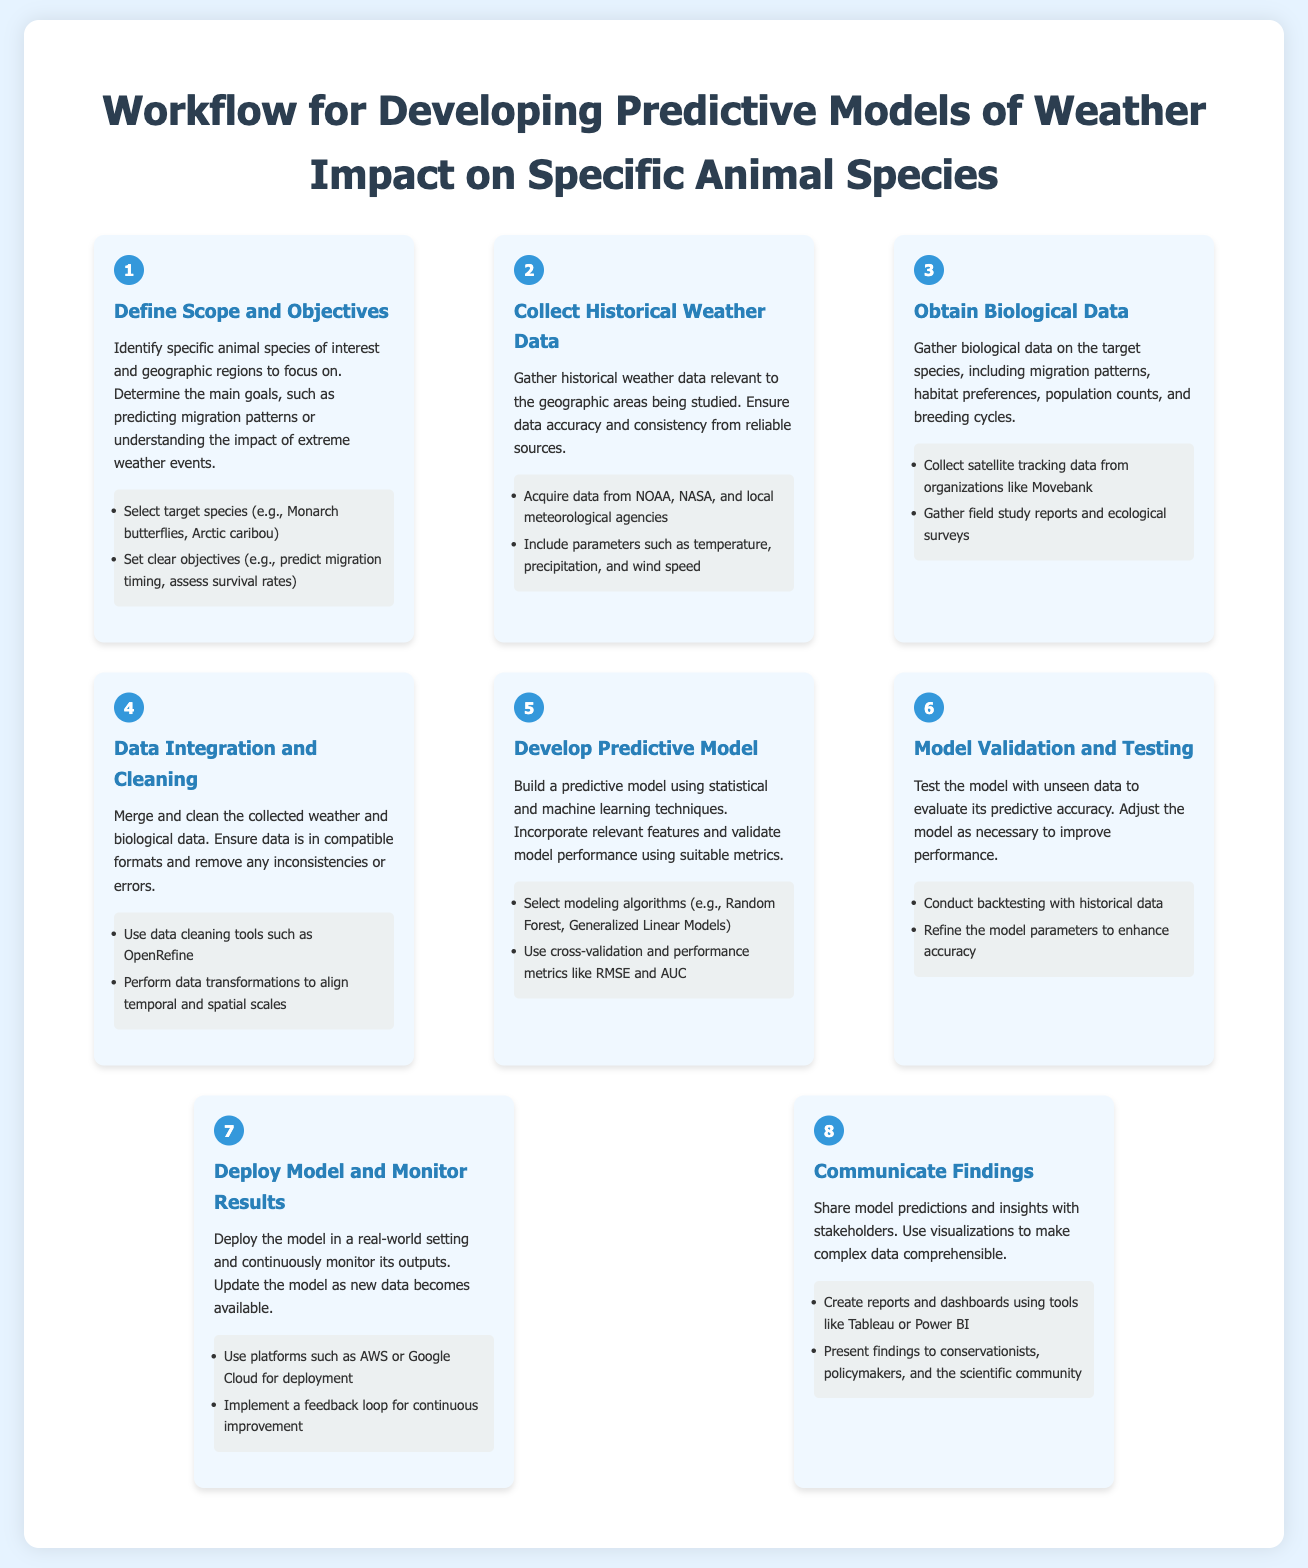What is the first step in the workflow? The first step in the workflow is to identify the specific animal species and geographic regions of interest.
Answer: Define Scope and Objectives What data sources are mentioned for collecting historical weather data? The document lists NOAA, NASA, and local meteorological agencies as data sources for weather data.
Answer: NOAA, NASA, and local meteorological agencies Which step involves merging and cleaning data? The step that involves merging and cleaning data is specifically focused on data integration.
Answer: Data Integration and Cleaning How many steps are there in total for developing the predictive model? The document outlines a total of eight steps in the workflow.
Answer: Eight What modeling algorithms are suggested in step five? The suggested modeling algorithms include Random Forest and Generalized Linear Models.
Answer: Random Forest, Generalized Linear Models What is a necessary action in the model validation step? A necessary action in the model validation step is to conduct backtesting with historical data.
Answer: Conduct backtesting with historical data What should be used for deployment as stated in the final step? The document suggests using platforms such as AWS or Google Cloud for deployment.
Answer: AWS or Google Cloud What is the purpose of communicating findings? The purpose of communicating findings is to share model predictions and insights with stakeholders.
Answer: Share model predictions and insights 